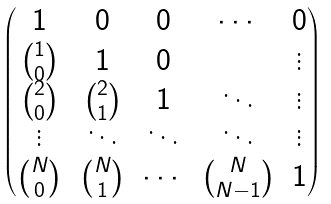<formula> <loc_0><loc_0><loc_500><loc_500>\begin{pmatrix} 1 & 0 & 0 & \cdots & 0 \\ \binom { 1 } { 0 } & 1 & 0 & & \vdots \\ \binom { 2 } { 0 } & \binom { 2 } { 1 } & 1 & \ddots & \vdots \\ \vdots & \ddots & \ddots & \ddots & \vdots \\ \binom { N } { 0 } & \binom { N } { 1 } & \cdots & \binom { N } { N - 1 } & 1 \end{pmatrix}</formula> 